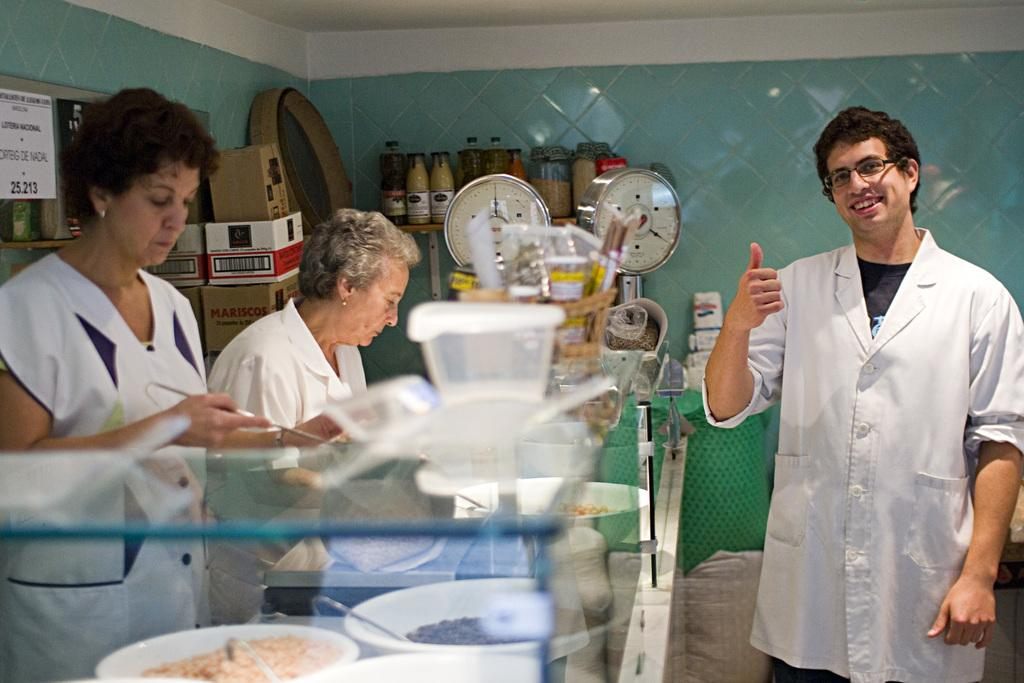How many people are in the image? There is a group of people in the image, but the exact number cannot be determined from the provided facts. What objects are present in the image besides the people? There are bowls, boxes, and bottles in the image. What type of brass fan can be seen in the image? There is no brass fan present in the image. 